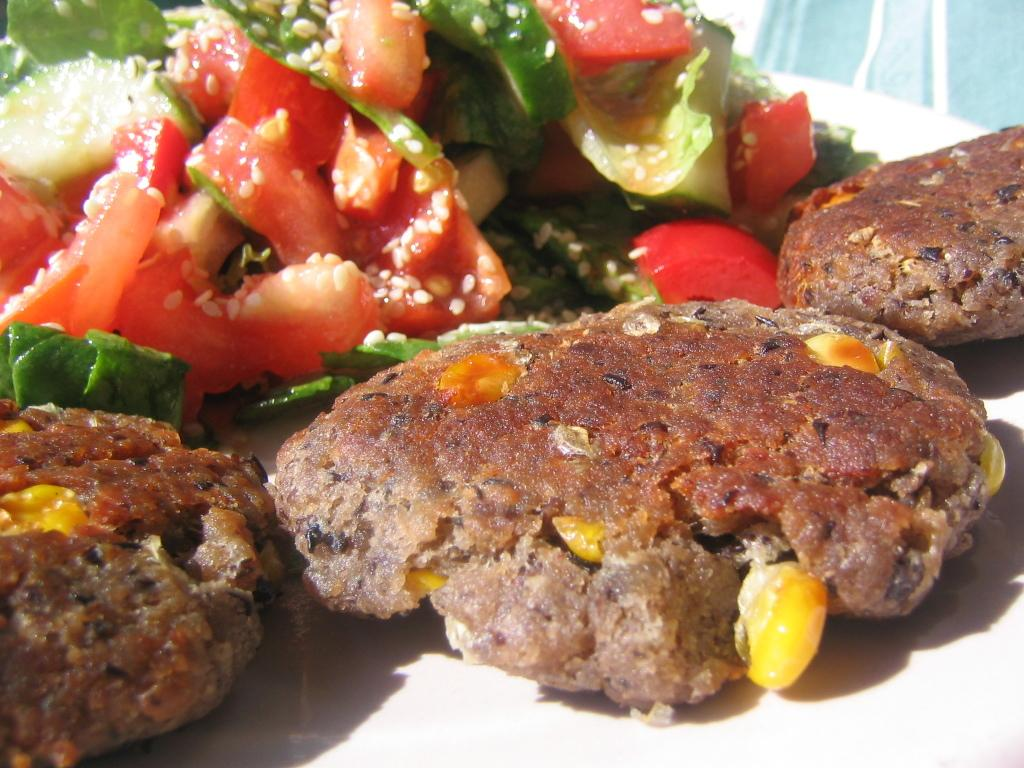What is present on the plates in the image? There is food in the plates in the image. What type of food can be seen in the image? There are vegetables (veggies) in the image. How many nails can be seen in the image? There are no nails present in the image. What is the value of the dime in the image? There is no dime present in the image. 